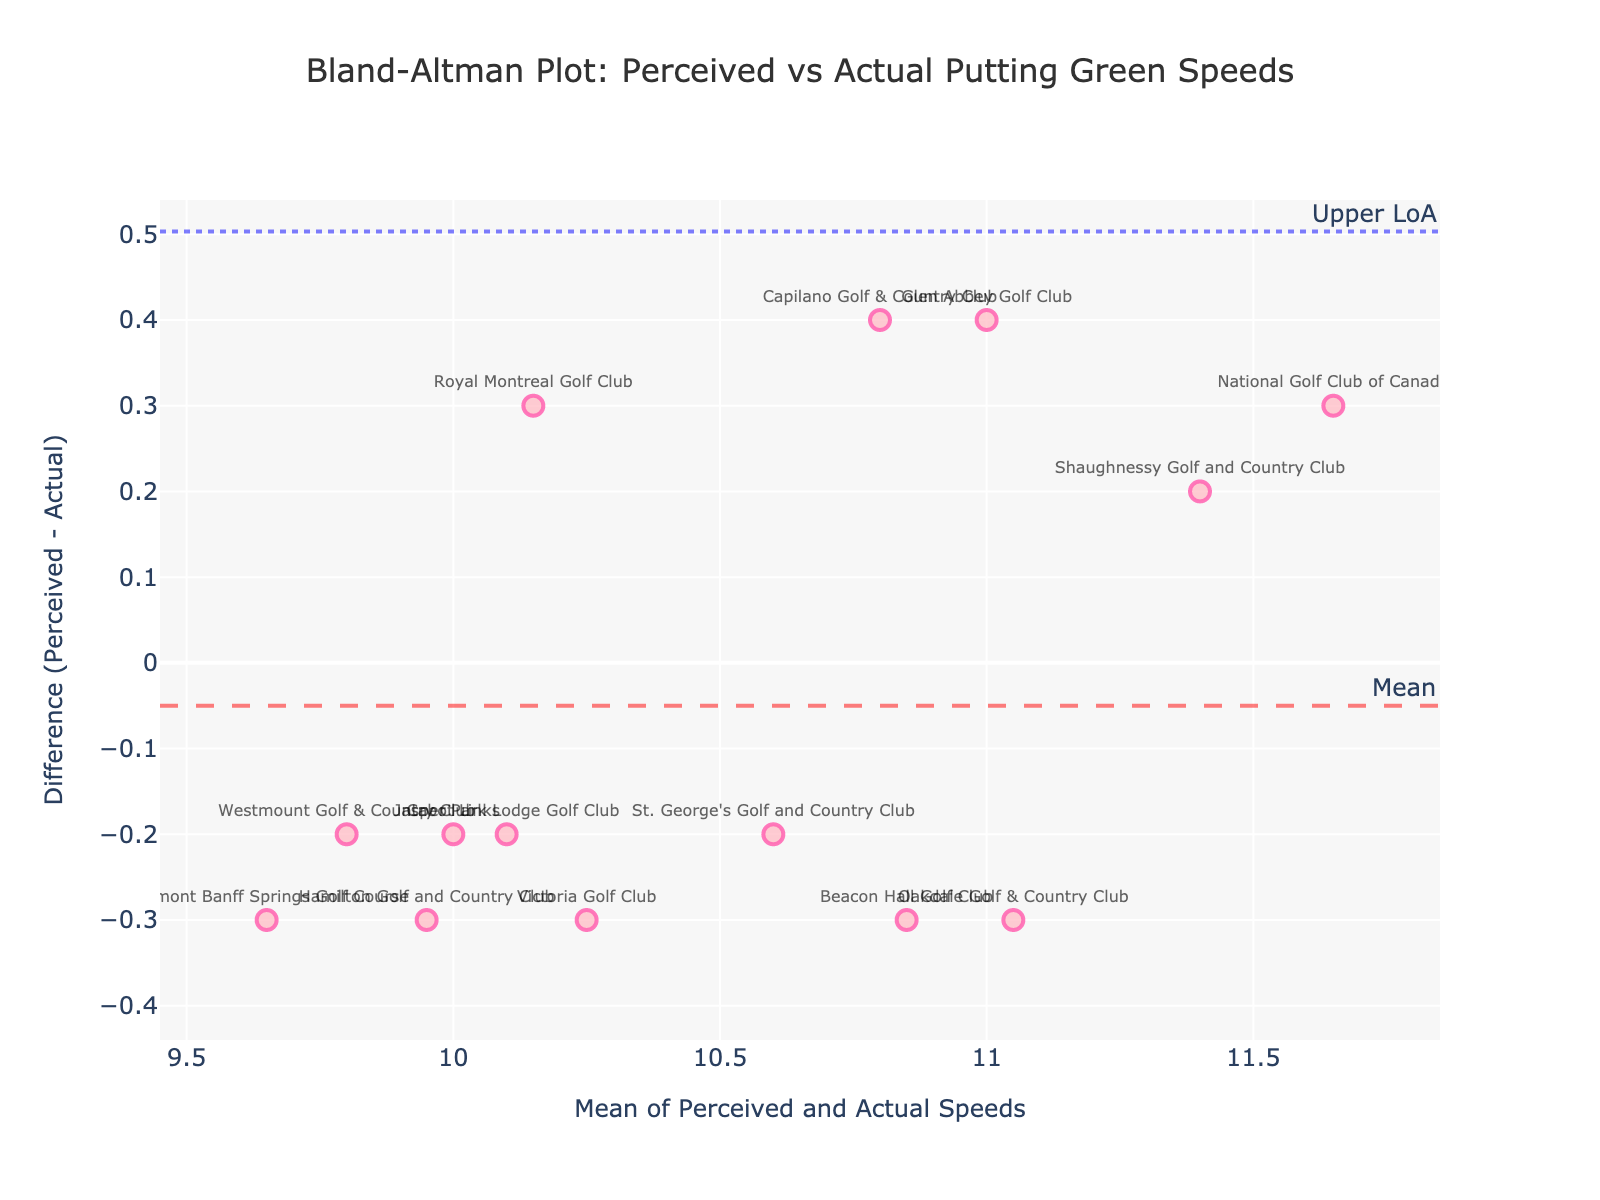what is the title of the plot? The title is placed at the top of the figure and provides a summary of the content. The title of this plot is "Bland-Altman Plot: Perceived vs Actual Putting Green Speeds."
Answer: Bland-Altman Plot: Perceived vs Actual Putting Green Speeds How is the mean difference indicated on the plot? The mean difference is indicated by a horizontal dashed line, labeled "Mean" and typically colored in a distinct way to stand out.
Answer: A dashed line labeled "Mean" What are the colors of the data points? By observing the plot, the data points are pink with a darker pink outline.
Answer: Pink with a darker pink outline How does the plot indicate the limits of agreement? The limits of agreement are marked by horizontal dotted lines on the plot. Each line is labeled accordingly.
Answer: Horizontal dotted lines labeled "Lower LoA" and "Upper LoA" What is the difference (Perceived - Actual) for Glen Abbey Golf Club? Check the data point labeled "Glen Abbey Golf Club" on the plot, find its position on the y-axis which represents the difference. Here it indicates a difference of 0.4.
Answer: 0.4 Which course has the highest perceived speed? Look at the data points and match it with their respective labels. The course "National Golf Club of Canada" has the highest perceived speed visible on the plot, which is 11.8.
Answer: National Golf Club of Canada Are most of the points within the limits of agreement? Observe the scatter of the data points relative to the dotted horizontal lines marking the limits of agreement. Most points appear between these lines.
Answer: Yes Do any courses have a higher Perceived Speed than Actual Speed? The data points where the difference (y-axis) is above 0 indicate Perceived Speed higher than the Actual Speed. Courses such as "Glen Abbey Golf Club" and "Capilano Golf & Country Club" meet this criterion.
Answer: Yes Which course shows the biggest discrepancy between perceived and actual speed? Find the point that is farthest from the horizontal line at y=0, either positive or negative. "National Golf Club of Canada" has the largest discrepancy, which is 0.3.
Answer: National Golf Club of Canada 